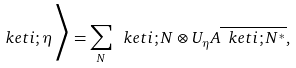Convert formula to latex. <formula><loc_0><loc_0><loc_500><loc_500>\ k e t { i ; \eta } \Big > = \sum _ { N } \ k e t { i ; N } \otimes U _ { \eta } A \overline { \ k e t { i ; N ^ { * } } } ,</formula> 